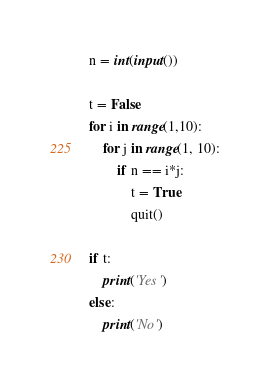Convert code to text. <code><loc_0><loc_0><loc_500><loc_500><_Python_>n = int(input())

t = False
for i in range(1,10):
    for j in range(1, 10):
        if n == i*j:
            t = True
            quit()

if t:
    print('Yes')
else:
    print('No')   </code> 